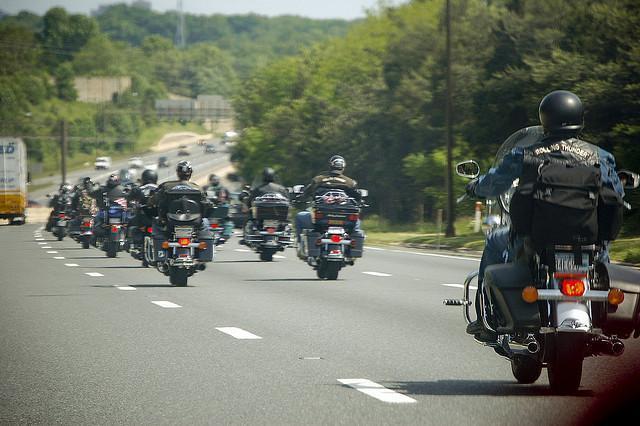How many more bikes than people?
Give a very brief answer. 0. How many motorcycles can be seen?
Give a very brief answer. 4. How many people are there?
Give a very brief answer. 2. 